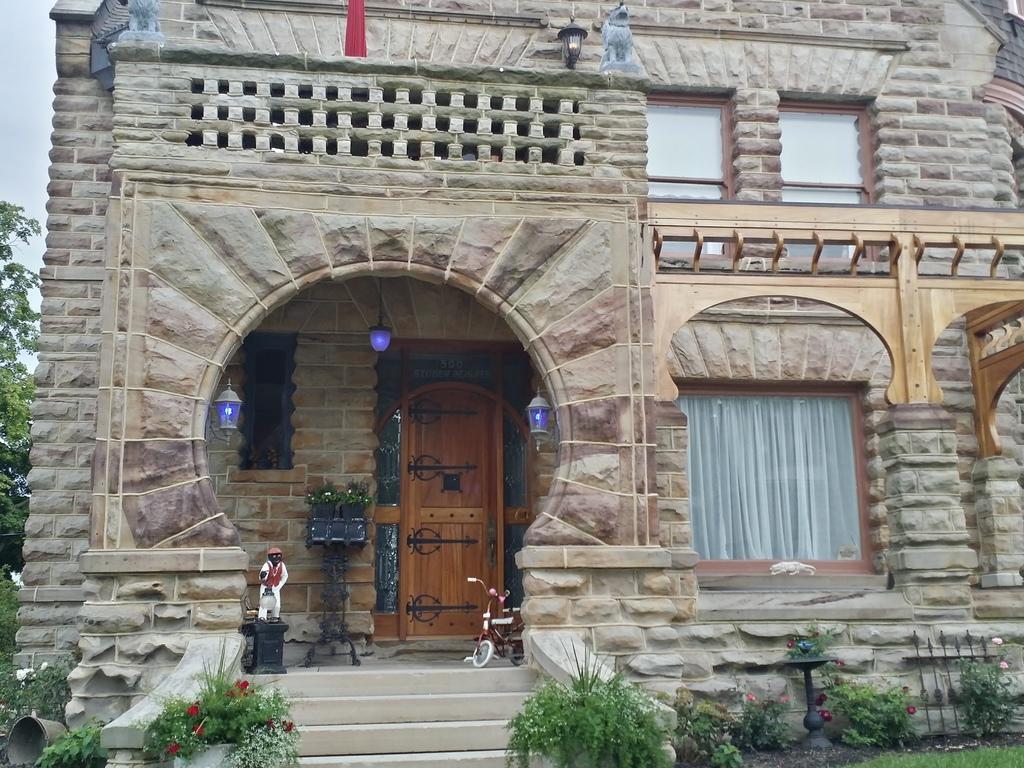In one or two sentences, can you explain what this image depicts? As we can see in the image there is building, door, statue, curtain and grass. There are plants, stairs, trees and at the top there is sky. 